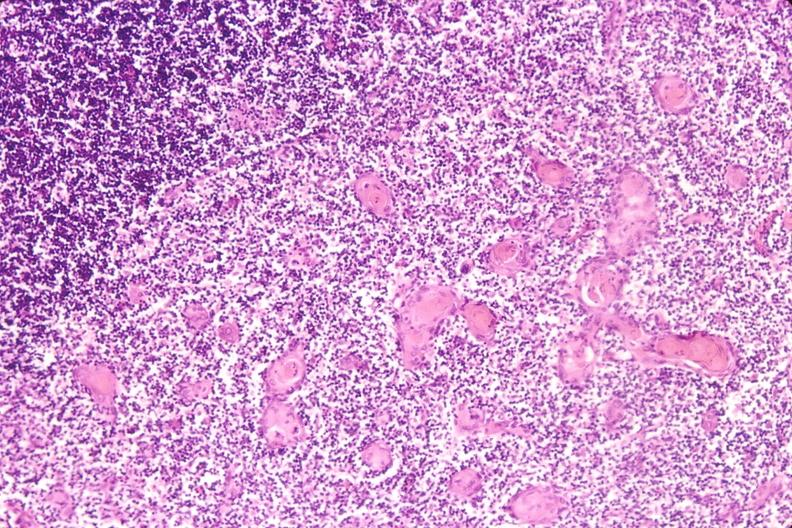what is present?
Answer the question using a single word or phrase. Hematologic 